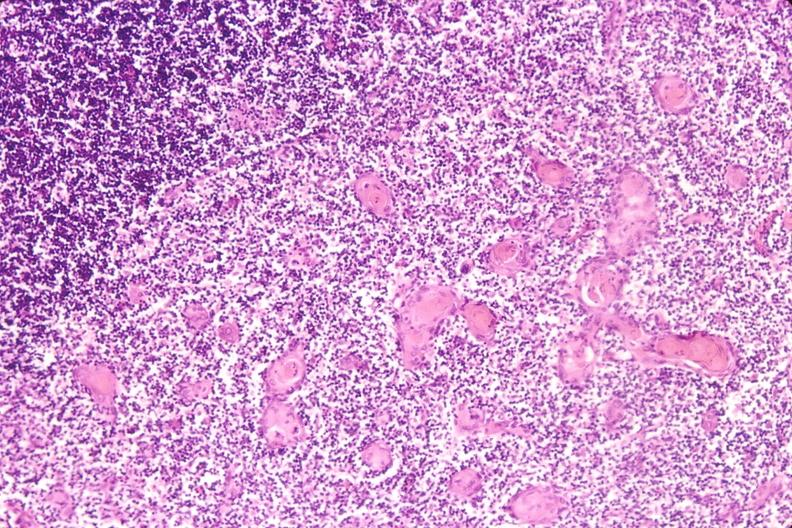what is present?
Answer the question using a single word or phrase. Hematologic 